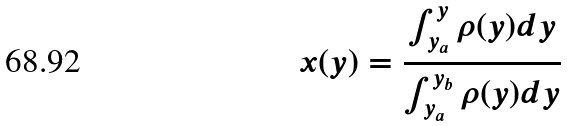<formula> <loc_0><loc_0><loc_500><loc_500>x ( y ) = \frac { \int _ { y _ { a } } ^ { y } \rho ( y ) d y } { \int _ { y _ { a } } ^ { y _ { b } } \rho ( y ) d y }</formula> 